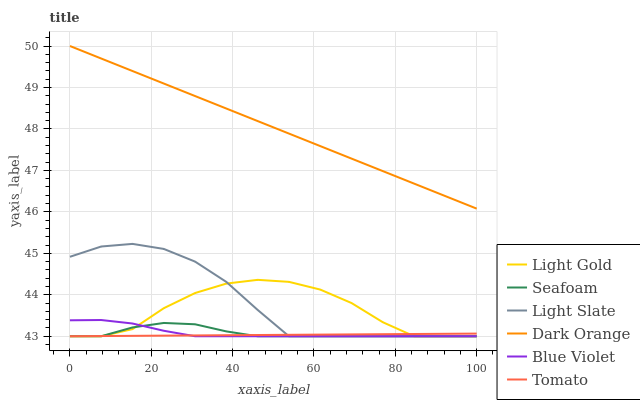Does Tomato have the minimum area under the curve?
Answer yes or no. Yes. Does Dark Orange have the maximum area under the curve?
Answer yes or no. Yes. Does Light Slate have the minimum area under the curve?
Answer yes or no. No. Does Light Slate have the maximum area under the curve?
Answer yes or no. No. Is Dark Orange the smoothest?
Answer yes or no. Yes. Is Light Gold the roughest?
Answer yes or no. Yes. Is Light Slate the smoothest?
Answer yes or no. No. Is Light Slate the roughest?
Answer yes or no. No. Does Tomato have the lowest value?
Answer yes or no. Yes. Does Dark Orange have the lowest value?
Answer yes or no. No. Does Dark Orange have the highest value?
Answer yes or no. Yes. Does Light Slate have the highest value?
Answer yes or no. No. Is Seafoam less than Dark Orange?
Answer yes or no. Yes. Is Dark Orange greater than Light Gold?
Answer yes or no. Yes. Does Seafoam intersect Tomato?
Answer yes or no. Yes. Is Seafoam less than Tomato?
Answer yes or no. No. Is Seafoam greater than Tomato?
Answer yes or no. No. Does Seafoam intersect Dark Orange?
Answer yes or no. No. 